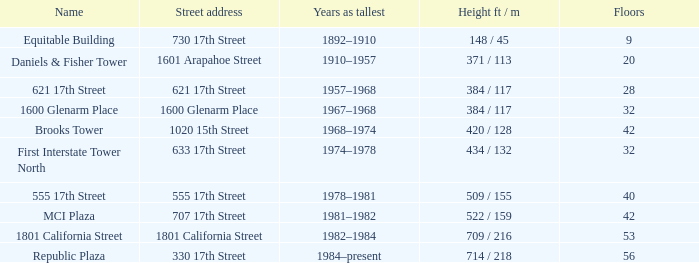What is the height of the building named 555 17th street? 509 / 155. 